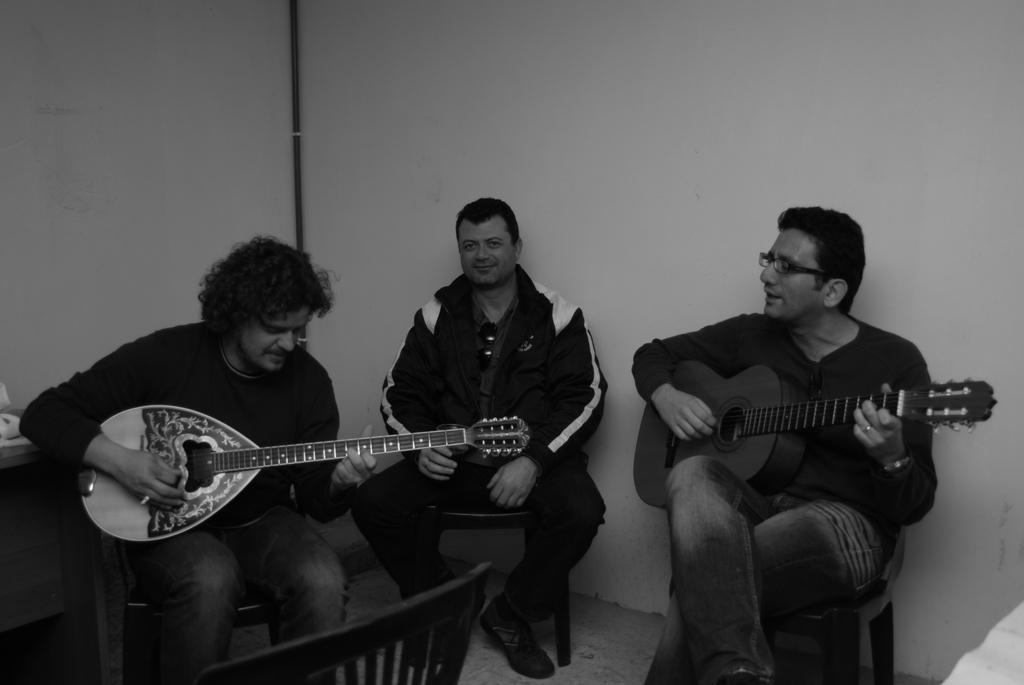Where was the image taken? The image was taken in a room. What are the people in the image doing? The people in the image are sitting on chairs and holding music instruments. What can be seen in the background of the image? There is a white color wall in the background of the image. How many quarters can be seen on the floor in the image? There are no quarters visible on the floor in the image. What type of sticks are the people using to play their instruments in the image? The image does not show any sticks being used to play the instruments; the people are holding the instruments directly. 